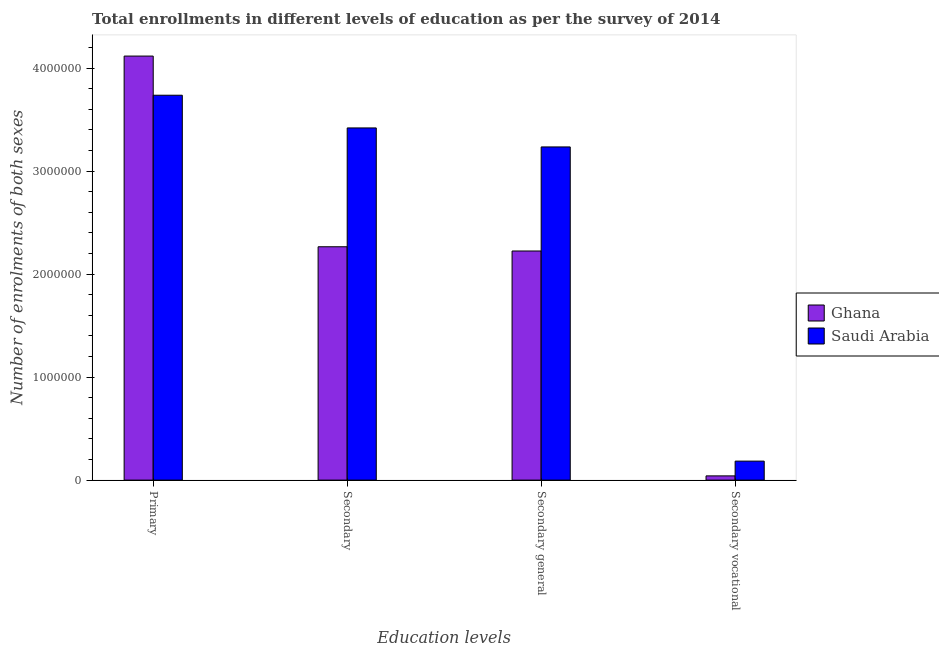How many different coloured bars are there?
Your answer should be very brief. 2. How many groups of bars are there?
Give a very brief answer. 4. Are the number of bars per tick equal to the number of legend labels?
Offer a very short reply. Yes. How many bars are there on the 4th tick from the left?
Give a very brief answer. 2. How many bars are there on the 1st tick from the right?
Give a very brief answer. 2. What is the label of the 1st group of bars from the left?
Provide a short and direct response. Primary. What is the number of enrolments in secondary general education in Saudi Arabia?
Give a very brief answer. 3.24e+06. Across all countries, what is the maximum number of enrolments in primary education?
Offer a terse response. 4.12e+06. Across all countries, what is the minimum number of enrolments in secondary education?
Provide a short and direct response. 2.27e+06. In which country was the number of enrolments in primary education maximum?
Your answer should be very brief. Ghana. What is the total number of enrolments in secondary general education in the graph?
Give a very brief answer. 5.46e+06. What is the difference between the number of enrolments in secondary general education in Saudi Arabia and that in Ghana?
Your answer should be compact. 1.01e+06. What is the difference between the number of enrolments in secondary vocational education in Saudi Arabia and the number of enrolments in primary education in Ghana?
Ensure brevity in your answer.  -3.93e+06. What is the average number of enrolments in secondary vocational education per country?
Give a very brief answer. 1.13e+05. What is the difference between the number of enrolments in primary education and number of enrolments in secondary education in Saudi Arabia?
Offer a very short reply. 3.18e+05. What is the ratio of the number of enrolments in secondary education in Ghana to that in Saudi Arabia?
Keep it short and to the point. 0.66. Is the difference between the number of enrolments in secondary education in Ghana and Saudi Arabia greater than the difference between the number of enrolments in secondary vocational education in Ghana and Saudi Arabia?
Ensure brevity in your answer.  No. What is the difference between the highest and the second highest number of enrolments in secondary vocational education?
Provide a short and direct response. 1.43e+05. What is the difference between the highest and the lowest number of enrolments in secondary education?
Your answer should be compact. 1.15e+06. What does the 2nd bar from the left in Secondary represents?
Offer a very short reply. Saudi Arabia. What does the 1st bar from the right in Secondary vocational represents?
Give a very brief answer. Saudi Arabia. Is it the case that in every country, the sum of the number of enrolments in primary education and number of enrolments in secondary education is greater than the number of enrolments in secondary general education?
Your answer should be very brief. Yes. Are all the bars in the graph horizontal?
Your answer should be very brief. No. Are the values on the major ticks of Y-axis written in scientific E-notation?
Make the answer very short. No. Does the graph contain any zero values?
Your answer should be compact. No. How many legend labels are there?
Keep it short and to the point. 2. How are the legend labels stacked?
Make the answer very short. Vertical. What is the title of the graph?
Offer a terse response. Total enrollments in different levels of education as per the survey of 2014. Does "French Polynesia" appear as one of the legend labels in the graph?
Your answer should be compact. No. What is the label or title of the X-axis?
Ensure brevity in your answer.  Education levels. What is the label or title of the Y-axis?
Offer a terse response. Number of enrolments of both sexes. What is the Number of enrolments of both sexes of Ghana in Primary?
Ensure brevity in your answer.  4.12e+06. What is the Number of enrolments of both sexes of Saudi Arabia in Primary?
Give a very brief answer. 3.74e+06. What is the Number of enrolments of both sexes of Ghana in Secondary?
Make the answer very short. 2.27e+06. What is the Number of enrolments of both sexes of Saudi Arabia in Secondary?
Your answer should be very brief. 3.42e+06. What is the Number of enrolments of both sexes in Ghana in Secondary general?
Provide a succinct answer. 2.22e+06. What is the Number of enrolments of both sexes in Saudi Arabia in Secondary general?
Ensure brevity in your answer.  3.24e+06. What is the Number of enrolments of both sexes of Ghana in Secondary vocational?
Your answer should be compact. 4.11e+04. What is the Number of enrolments of both sexes in Saudi Arabia in Secondary vocational?
Provide a short and direct response. 1.84e+05. Across all Education levels, what is the maximum Number of enrolments of both sexes of Ghana?
Your response must be concise. 4.12e+06. Across all Education levels, what is the maximum Number of enrolments of both sexes of Saudi Arabia?
Keep it short and to the point. 3.74e+06. Across all Education levels, what is the minimum Number of enrolments of both sexes of Ghana?
Provide a short and direct response. 4.11e+04. Across all Education levels, what is the minimum Number of enrolments of both sexes of Saudi Arabia?
Ensure brevity in your answer.  1.84e+05. What is the total Number of enrolments of both sexes of Ghana in the graph?
Your answer should be compact. 8.65e+06. What is the total Number of enrolments of both sexes in Saudi Arabia in the graph?
Make the answer very short. 1.06e+07. What is the difference between the Number of enrolments of both sexes of Ghana in Primary and that in Secondary?
Your response must be concise. 1.85e+06. What is the difference between the Number of enrolments of both sexes of Saudi Arabia in Primary and that in Secondary?
Your response must be concise. 3.18e+05. What is the difference between the Number of enrolments of both sexes in Ghana in Primary and that in Secondary general?
Your answer should be very brief. 1.89e+06. What is the difference between the Number of enrolments of both sexes in Saudi Arabia in Primary and that in Secondary general?
Your answer should be very brief. 5.02e+05. What is the difference between the Number of enrolments of both sexes of Ghana in Primary and that in Secondary vocational?
Your response must be concise. 4.08e+06. What is the difference between the Number of enrolments of both sexes in Saudi Arabia in Primary and that in Secondary vocational?
Provide a succinct answer. 3.55e+06. What is the difference between the Number of enrolments of both sexes in Ghana in Secondary and that in Secondary general?
Your answer should be compact. 4.11e+04. What is the difference between the Number of enrolments of both sexes of Saudi Arabia in Secondary and that in Secondary general?
Provide a succinct answer. 1.84e+05. What is the difference between the Number of enrolments of both sexes in Ghana in Secondary and that in Secondary vocational?
Provide a short and direct response. 2.22e+06. What is the difference between the Number of enrolments of both sexes of Saudi Arabia in Secondary and that in Secondary vocational?
Keep it short and to the point. 3.24e+06. What is the difference between the Number of enrolments of both sexes of Ghana in Secondary general and that in Secondary vocational?
Make the answer very short. 2.18e+06. What is the difference between the Number of enrolments of both sexes of Saudi Arabia in Secondary general and that in Secondary vocational?
Provide a succinct answer. 3.05e+06. What is the difference between the Number of enrolments of both sexes in Ghana in Primary and the Number of enrolments of both sexes in Saudi Arabia in Secondary?
Make the answer very short. 6.98e+05. What is the difference between the Number of enrolments of both sexes of Ghana in Primary and the Number of enrolments of both sexes of Saudi Arabia in Secondary general?
Provide a short and direct response. 8.82e+05. What is the difference between the Number of enrolments of both sexes of Ghana in Primary and the Number of enrolments of both sexes of Saudi Arabia in Secondary vocational?
Your response must be concise. 3.93e+06. What is the difference between the Number of enrolments of both sexes of Ghana in Secondary and the Number of enrolments of both sexes of Saudi Arabia in Secondary general?
Keep it short and to the point. -9.69e+05. What is the difference between the Number of enrolments of both sexes of Ghana in Secondary and the Number of enrolments of both sexes of Saudi Arabia in Secondary vocational?
Your answer should be compact. 2.08e+06. What is the difference between the Number of enrolments of both sexes in Ghana in Secondary general and the Number of enrolments of both sexes in Saudi Arabia in Secondary vocational?
Your answer should be compact. 2.04e+06. What is the average Number of enrolments of both sexes of Ghana per Education levels?
Offer a terse response. 2.16e+06. What is the average Number of enrolments of both sexes of Saudi Arabia per Education levels?
Offer a terse response. 2.64e+06. What is the difference between the Number of enrolments of both sexes in Ghana and Number of enrolments of both sexes in Saudi Arabia in Primary?
Your answer should be very brief. 3.80e+05. What is the difference between the Number of enrolments of both sexes in Ghana and Number of enrolments of both sexes in Saudi Arabia in Secondary?
Provide a succinct answer. -1.15e+06. What is the difference between the Number of enrolments of both sexes of Ghana and Number of enrolments of both sexes of Saudi Arabia in Secondary general?
Your answer should be very brief. -1.01e+06. What is the difference between the Number of enrolments of both sexes of Ghana and Number of enrolments of both sexes of Saudi Arabia in Secondary vocational?
Give a very brief answer. -1.43e+05. What is the ratio of the Number of enrolments of both sexes in Ghana in Primary to that in Secondary?
Provide a succinct answer. 1.82. What is the ratio of the Number of enrolments of both sexes of Saudi Arabia in Primary to that in Secondary?
Your answer should be very brief. 1.09. What is the ratio of the Number of enrolments of both sexes in Ghana in Primary to that in Secondary general?
Your response must be concise. 1.85. What is the ratio of the Number of enrolments of both sexes in Saudi Arabia in Primary to that in Secondary general?
Your response must be concise. 1.16. What is the ratio of the Number of enrolments of both sexes of Ghana in Primary to that in Secondary vocational?
Make the answer very short. 100.26. What is the ratio of the Number of enrolments of both sexes in Saudi Arabia in Primary to that in Secondary vocational?
Keep it short and to the point. 20.26. What is the ratio of the Number of enrolments of both sexes in Ghana in Secondary to that in Secondary general?
Provide a succinct answer. 1.02. What is the ratio of the Number of enrolments of both sexes in Saudi Arabia in Secondary to that in Secondary general?
Keep it short and to the point. 1.06. What is the ratio of the Number of enrolments of both sexes of Ghana in Secondary to that in Secondary vocational?
Keep it short and to the point. 55.17. What is the ratio of the Number of enrolments of both sexes of Saudi Arabia in Secondary to that in Secondary vocational?
Provide a succinct answer. 18.54. What is the ratio of the Number of enrolments of both sexes of Ghana in Secondary general to that in Secondary vocational?
Offer a very short reply. 54.17. What is the ratio of the Number of enrolments of both sexes of Saudi Arabia in Secondary general to that in Secondary vocational?
Offer a very short reply. 17.54. What is the difference between the highest and the second highest Number of enrolments of both sexes of Ghana?
Your answer should be compact. 1.85e+06. What is the difference between the highest and the second highest Number of enrolments of both sexes of Saudi Arabia?
Make the answer very short. 3.18e+05. What is the difference between the highest and the lowest Number of enrolments of both sexes of Ghana?
Provide a succinct answer. 4.08e+06. What is the difference between the highest and the lowest Number of enrolments of both sexes in Saudi Arabia?
Offer a very short reply. 3.55e+06. 